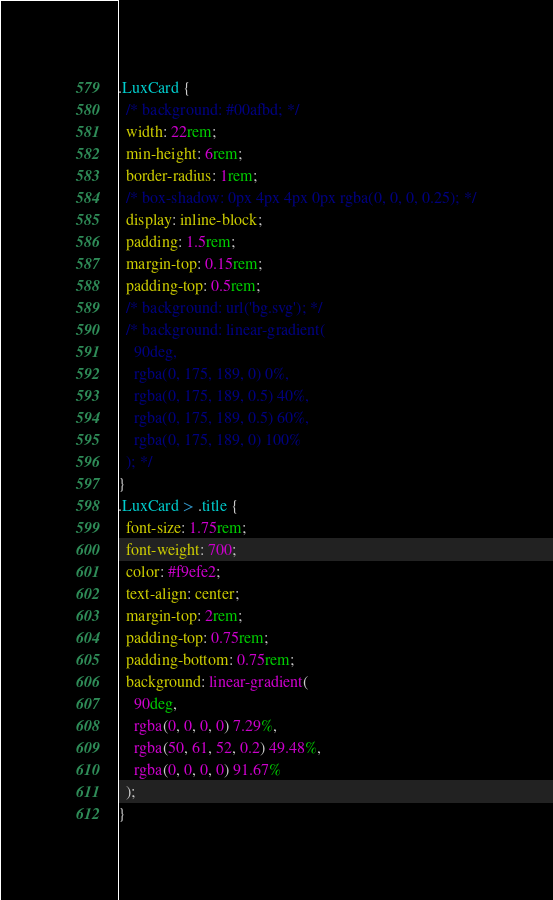Convert code to text. <code><loc_0><loc_0><loc_500><loc_500><_CSS_>.LuxCard {
  /* background: #00afbd; */
  width: 22rem;
  min-height: 6rem;
  border-radius: 1rem;
  /* box-shadow: 0px 4px 4px 0px rgba(0, 0, 0, 0.25); */
  display: inline-block;
  padding: 1.5rem;
  margin-top: 0.15rem;
  padding-top: 0.5rem;
  /* background: url('bg.svg'); */
  /* background: linear-gradient(
    90deg,
    rgba(0, 175, 189, 0) 0%,
    rgba(0, 175, 189, 0.5) 40%,
    rgba(0, 175, 189, 0.5) 60%,
    rgba(0, 175, 189, 0) 100%
  ); */
}
.LuxCard > .title {
  font-size: 1.75rem;
  font-weight: 700;
  color: #f9efe2;
  text-align: center;
  margin-top: 2rem;
  padding-top: 0.75rem;
  padding-bottom: 0.75rem;
  background: linear-gradient(
    90deg,
    rgba(0, 0, 0, 0) 7.29%,
    rgba(50, 61, 52, 0.2) 49.48%,
    rgba(0, 0, 0, 0) 91.67%
  );
}
</code> 